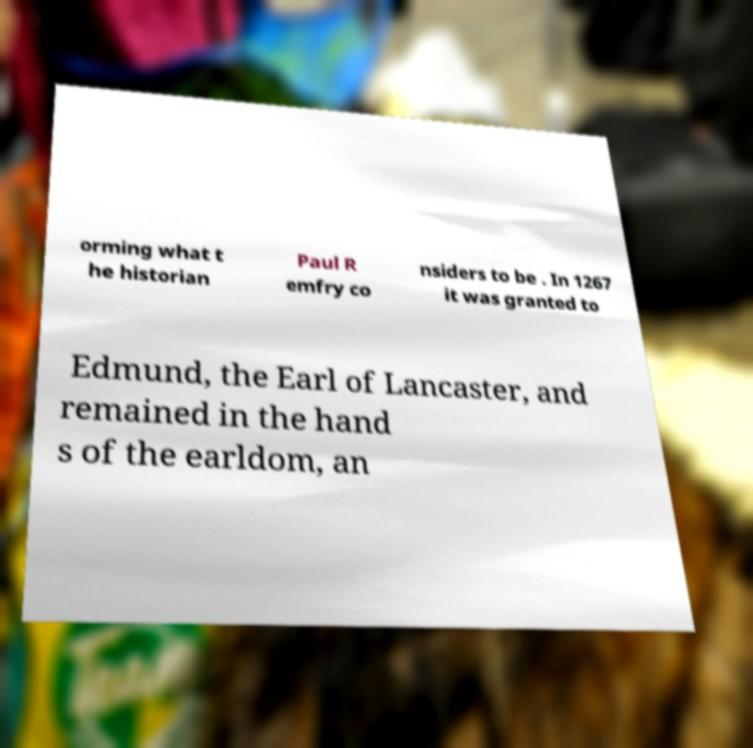For documentation purposes, I need the text within this image transcribed. Could you provide that? orming what t he historian Paul R emfry co nsiders to be . In 1267 it was granted to Edmund, the Earl of Lancaster, and remained in the hand s of the earldom, an 